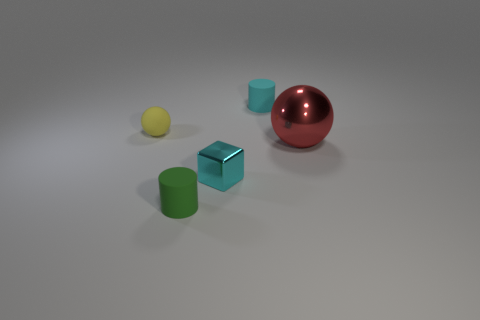Add 4 large yellow cylinders. How many objects exist? 9 Subtract all cylinders. How many objects are left? 3 Add 1 small green things. How many small green things are left? 2 Add 4 cyan blocks. How many cyan blocks exist? 5 Subtract 0 blue spheres. How many objects are left? 5 Subtract all green rubber things. Subtract all cylinders. How many objects are left? 2 